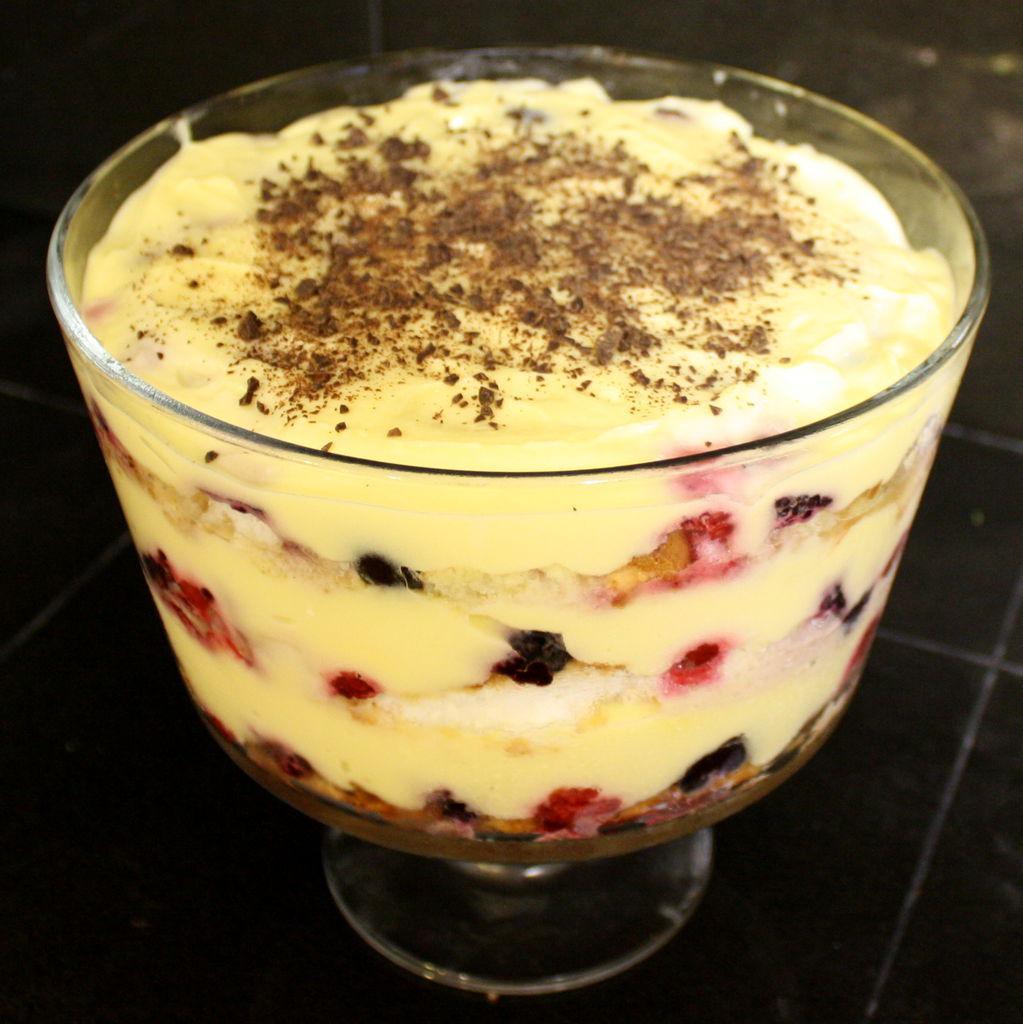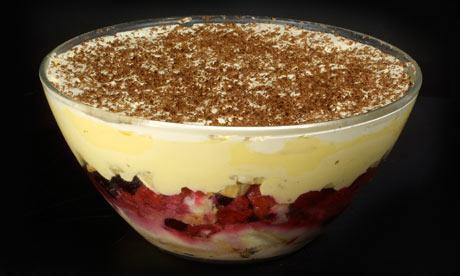The first image is the image on the left, the second image is the image on the right. Evaluate the accuracy of this statement regarding the images: "An image shows a dessert with garnish that includes red berries and a green leaf.". Is it true? Answer yes or no. No. 